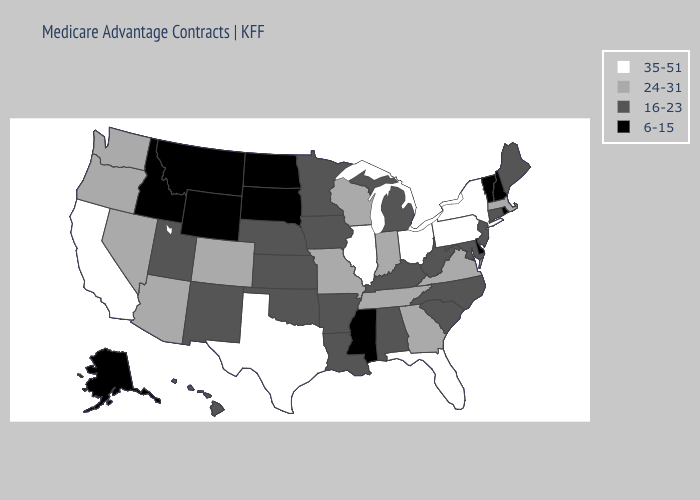What is the value of Illinois?
Give a very brief answer. 35-51. Does Georgia have a higher value than West Virginia?
Keep it brief. Yes. Name the states that have a value in the range 16-23?
Give a very brief answer. Alabama, Arkansas, Connecticut, Hawaii, Iowa, Kansas, Kentucky, Louisiana, Maryland, Maine, Michigan, Minnesota, North Carolina, Nebraska, New Jersey, New Mexico, Oklahoma, South Carolina, Utah, West Virginia. What is the value of Florida?
Concise answer only. 35-51. Name the states that have a value in the range 24-31?
Quick response, please. Arizona, Colorado, Georgia, Indiana, Massachusetts, Missouri, Nevada, Oregon, Tennessee, Virginia, Washington, Wisconsin. Does Nevada have the highest value in the West?
Short answer required. No. What is the value of Wyoming?
Answer briefly. 6-15. What is the highest value in the South ?
Concise answer only. 35-51. Does Tennessee have the same value as Illinois?
Give a very brief answer. No. Among the states that border New Jersey , does Pennsylvania have the highest value?
Keep it brief. Yes. Among the states that border Louisiana , which have the lowest value?
Quick response, please. Mississippi. Which states have the highest value in the USA?
Concise answer only. California, Florida, Illinois, New York, Ohio, Pennsylvania, Texas. What is the value of West Virginia?
Answer briefly. 16-23. Name the states that have a value in the range 6-15?
Write a very short answer. Alaska, Delaware, Idaho, Mississippi, Montana, North Dakota, New Hampshire, Rhode Island, South Dakota, Vermont, Wyoming. Among the states that border Utah , does New Mexico have the highest value?
Give a very brief answer. No. 